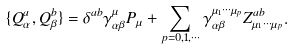<formula> <loc_0><loc_0><loc_500><loc_500>\{ Q _ { \alpha } ^ { a } , Q _ { \beta } ^ { b } \} = \delta ^ { a b } \gamma _ { \alpha \beta } ^ { \mu } P _ { \mu } + \sum _ { p = 0 , 1 , \cdots } \gamma _ { \alpha \beta } ^ { \mu _ { 1 } \cdots \mu _ { p } } Z _ { \mu _ { 1 } \cdots \mu _ { p } } ^ { a b } .</formula> 